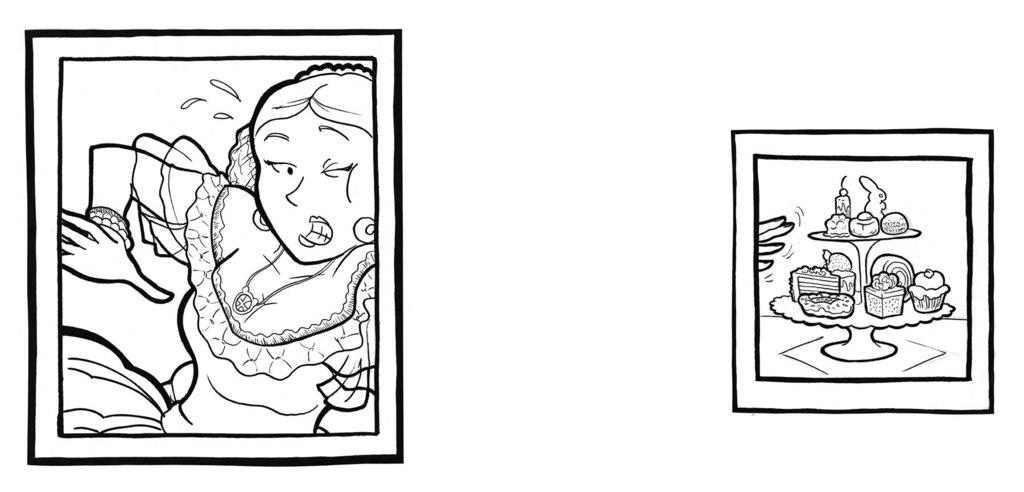What is depicted in the left corner of the image? There is an image of a woman in the left corner of the image. What can be found in the right corner of the image? There are eatables placed on an object in the right corner of the image. How many rail tracks can be seen in the image? There are no rail tracks present in the image. What type of chin is visible on the woman in the image? There is no chin visible on the woman in the image, as it is a two-dimensional representation. 